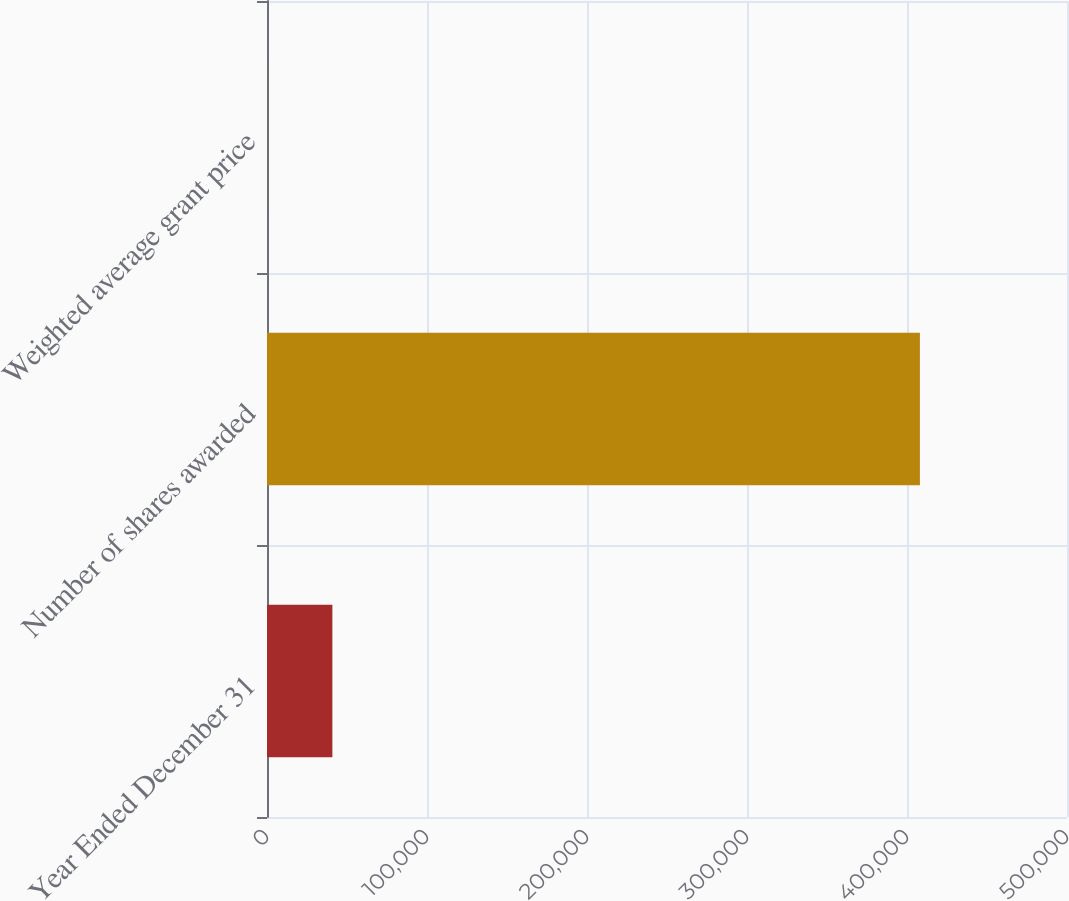<chart> <loc_0><loc_0><loc_500><loc_500><bar_chart><fcel>Year Ended December 31<fcel>Number of shares awarded<fcel>Weighted average grant price<nl><fcel>40859.1<fcel>408064<fcel>58.54<nl></chart> 